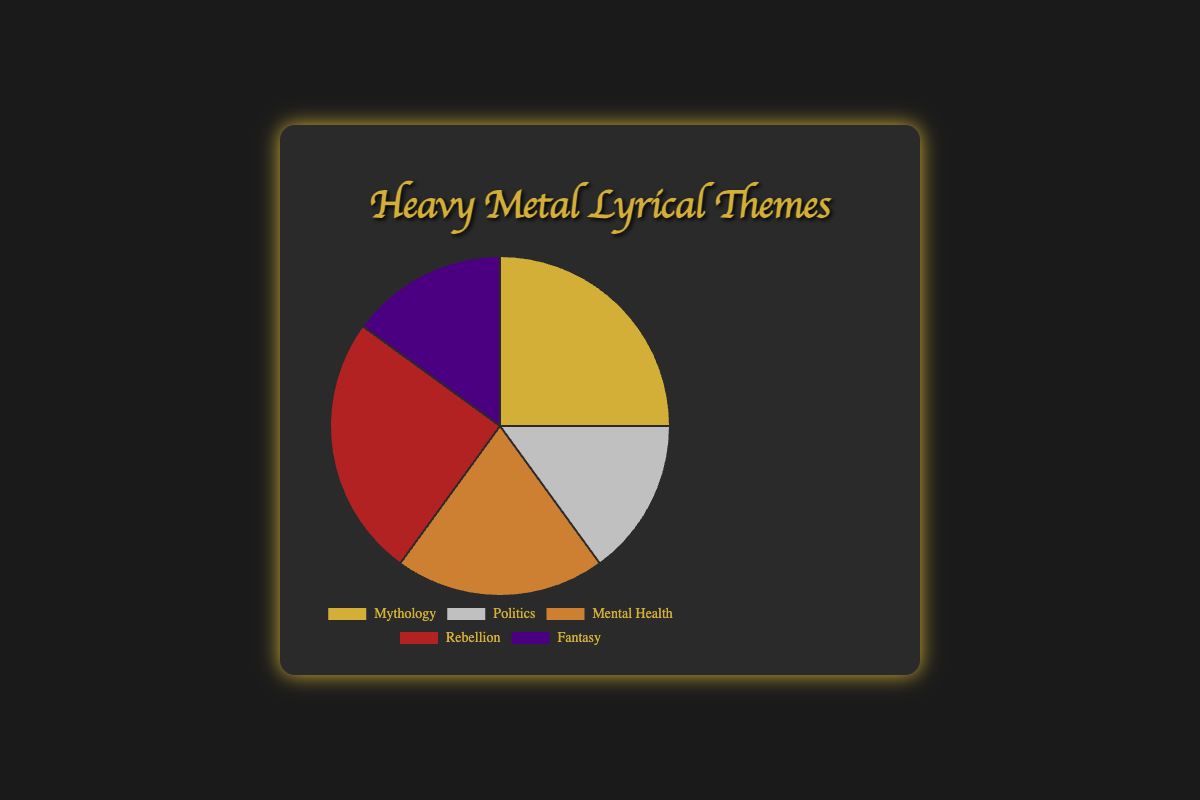Which lyrical theme is represented by the color gold? The chart provides visual cues to identify the colors associated with each lyrical theme. From the chart, the color gold corresponds to one of these themes.
Answer: Mythology Which two lyrical themes have the same percentage distribution? By examining the pie chart, we can see that mythology and rebellion share the same slice size, both at 25% each.
Answer: Mythology and Rebellion What is the total percentage of songs that cover Mythology and Fantasy themes? To find the total, add the percentages of Mythology (25%) and Fantasy (15%): 25% + 15% = 40%.
Answer: 40% How does the percentage of songs with mental health themes compare to those with fantasy themes? By comparing the slices, Mental Health is represented by a 20% slice, while Fantasy has a 15% slice. Mental Health has a higher percentage.
Answer: Mental Health is higher by 5% What proportion of songs are dedicated to politics and mental health combined? Sum the percentages of Politics (15%) and Mental Health (20%): 15% + 20% = 35%.
Answer: 35% Which segment, when combined with rebellion, would cover half of the total distribution? Rebellion has 25%, so we need another theme contributing 25% to make it 50%. Mythology has the same percentage (25%), making the total 50% when combined.
Answer: Mythology Is the percentage of songs themed around rebellion greater than, less than, or equal to the sum of songs themed around politics and fantasy? Rebellion is 25%. The sum of politics (15%) and fantasy (15%) is 30%. Thus, rebellion is less than the combined percentage of politics and fantasy.
Answer: Less than Identify the theme with the smallest representation and its color. Look for the smallest slice, which is Fantasy, and check its associated color.
Answer: Fantasy, indigo How many percentage points more or less is the Fantasy theme compared to the Politics theme? Compute the difference between Fantasy (15%) and Politics (15%). Both are equal, so there is no difference.
Answer: 0 (equal) What is the sum of the percentages of themes that are depicted with metallic colors (gold, silver, bronze)? The metallic colors are gold (Mythology - 25%), silver (Politics - 15%), and bronze (Mental Health - 20%). Sum them up: 25% + 15% + 20% = 60%.
Answer: 60% 